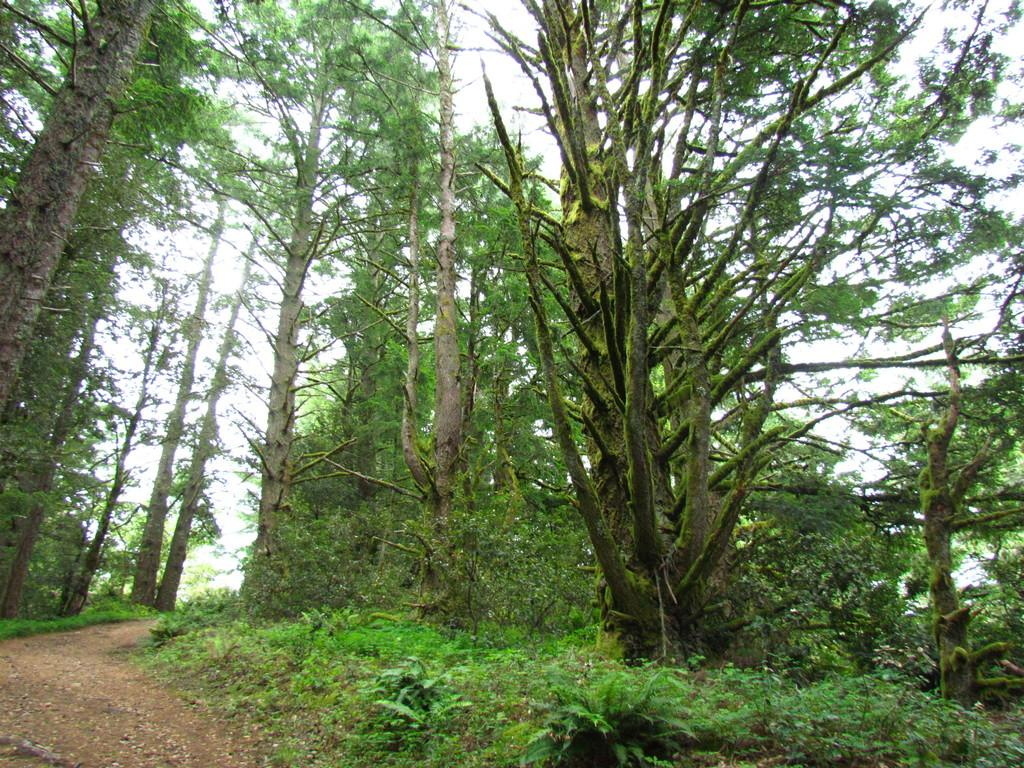What type of surface can be seen in the image? Grass is present on the surface of the image. What is the main feature of the image? There is a road in the image. What can be seen in the background of the image? There are trees and the sky visible in the background of the image. What type of plate is being used to serve the food in the image? There is no food or plate present in the image; it features a road, grass, trees, and the sky. 